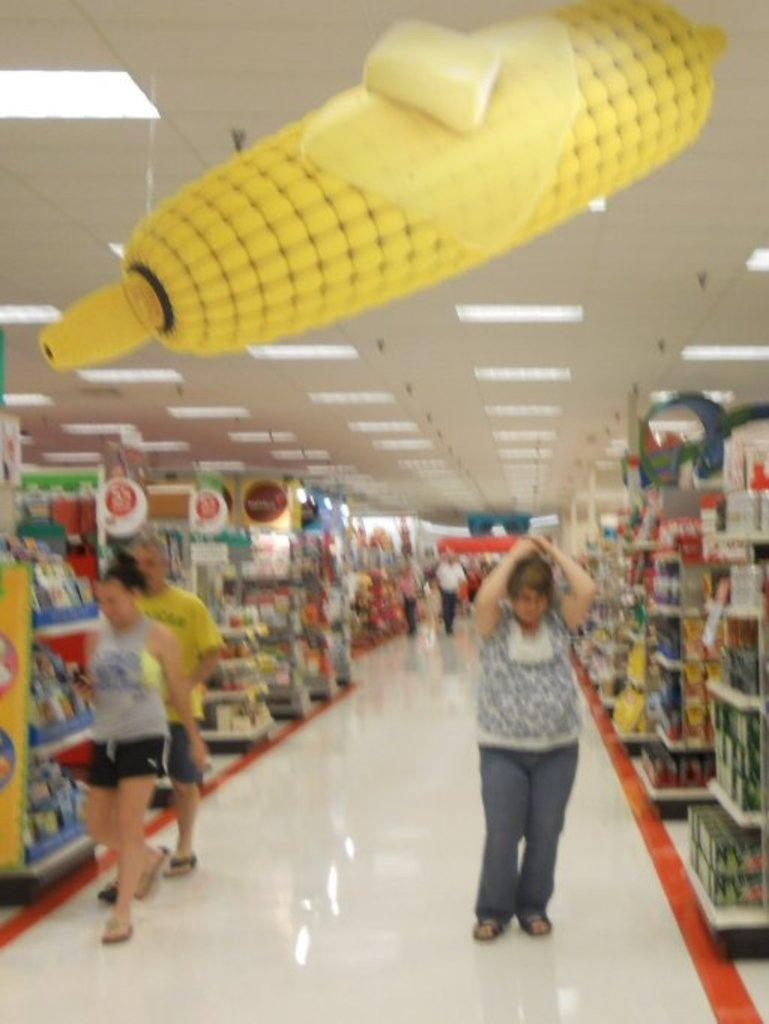Who or what can be seen in the image? There are people in the image. What is the surface beneath the people's feet? There is a floor visible in the image. What type of objects are present in the image? There are boards and objects in racks in the image. What is providing illumination in the image? Lights are present at the top of the image. What is above the people in the image? There is a ceiling visible in the image. What type of vegetation can be seen at the top of the image? Maize is observable at the top of the image. What team is playing in the room depicted in the image? There is no room or team present in the image; it features people, boards, objects in racks, lights, a ceiling, and maize. 